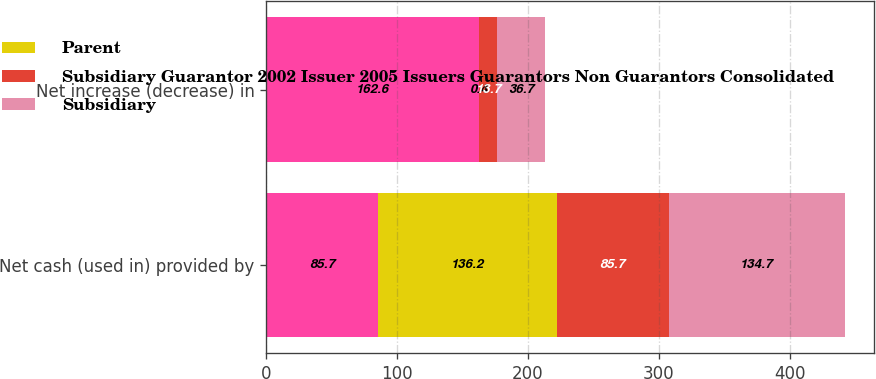Convert chart to OTSL. <chart><loc_0><loc_0><loc_500><loc_500><stacked_bar_chart><ecel><fcel>Net cash (used in) provided by<fcel>Net increase (decrease) in<nl><fcel>nan<fcel>85.7<fcel>162.6<nl><fcel>Parent<fcel>136.2<fcel>0.4<nl><fcel>Subsidiary Guarantor 2002 Issuer 2005 Issuers Guarantors Non Guarantors Consolidated<fcel>85.7<fcel>13.7<nl><fcel>Subsidiary<fcel>134.7<fcel>36.7<nl></chart> 